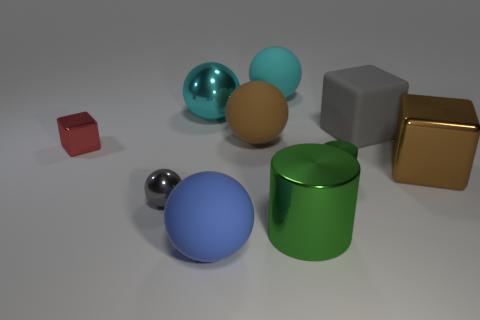What number of small things are either matte spheres or metal cylinders?
Your answer should be compact. 1. What size is the brown metallic cube?
Offer a terse response. Large. The gray metallic thing has what shape?
Offer a terse response. Sphere. Is there any other thing that is the same shape as the red thing?
Your response must be concise. Yes. Are there fewer big brown rubber balls on the left side of the small gray metallic ball than blue blocks?
Your response must be concise. No. There is a metallic object that is in front of the gray ball; is it the same color as the tiny metallic cylinder?
Your response must be concise. Yes. What number of matte things are big cylinders or red cylinders?
Ensure brevity in your answer.  0. There is a small block that is the same material as the tiny gray object; what is its color?
Provide a short and direct response. Red. What number of cylinders are tiny brown objects or large green things?
Provide a short and direct response. 1. What number of things are either gray things or balls that are behind the large metal block?
Offer a very short reply. 5. 